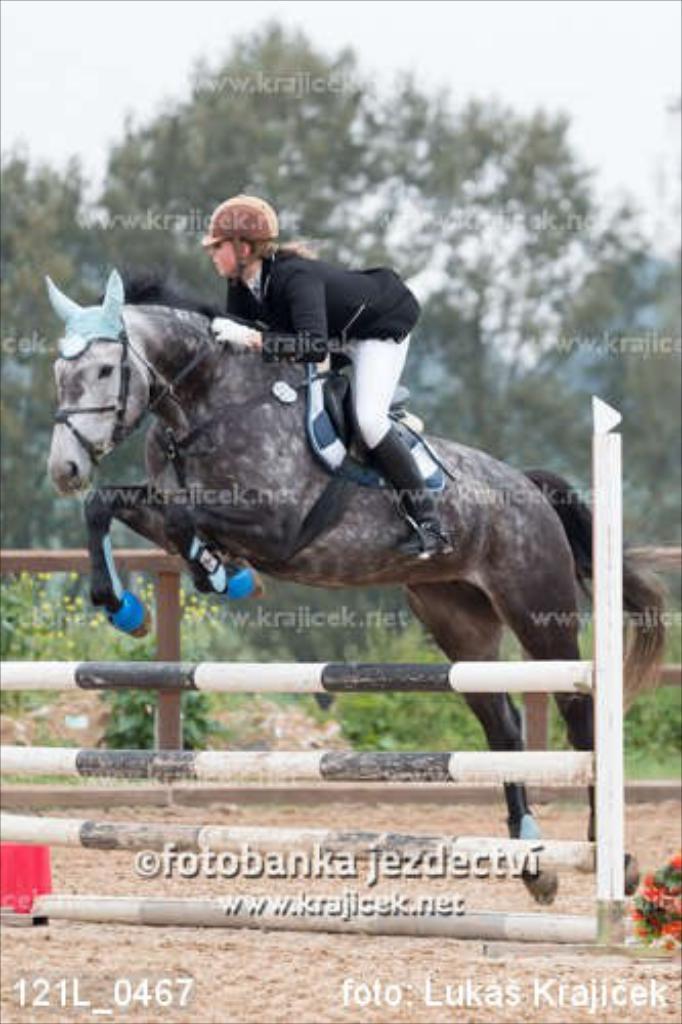Can you describe this image briefly? In this image the person is riding a horse through a barricade, and behind that we can see trees and plants and the person is wearing an helmet 